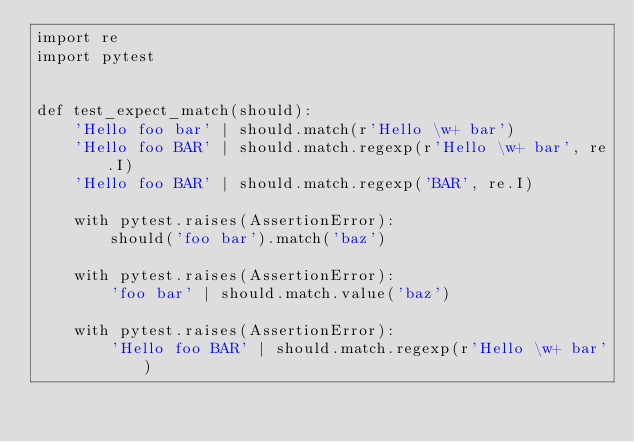Convert code to text. <code><loc_0><loc_0><loc_500><loc_500><_Python_>import re
import pytest


def test_expect_match(should):
    'Hello foo bar' | should.match(r'Hello \w+ bar')
    'Hello foo BAR' | should.match.regexp(r'Hello \w+ bar', re.I)
    'Hello foo BAR' | should.match.regexp('BAR', re.I)

    with pytest.raises(AssertionError):
        should('foo bar').match('baz')

    with pytest.raises(AssertionError):
        'foo bar' | should.match.value('baz')

    with pytest.raises(AssertionError):
        'Hello foo BAR' | should.match.regexp(r'Hello \w+ bar')
</code> 